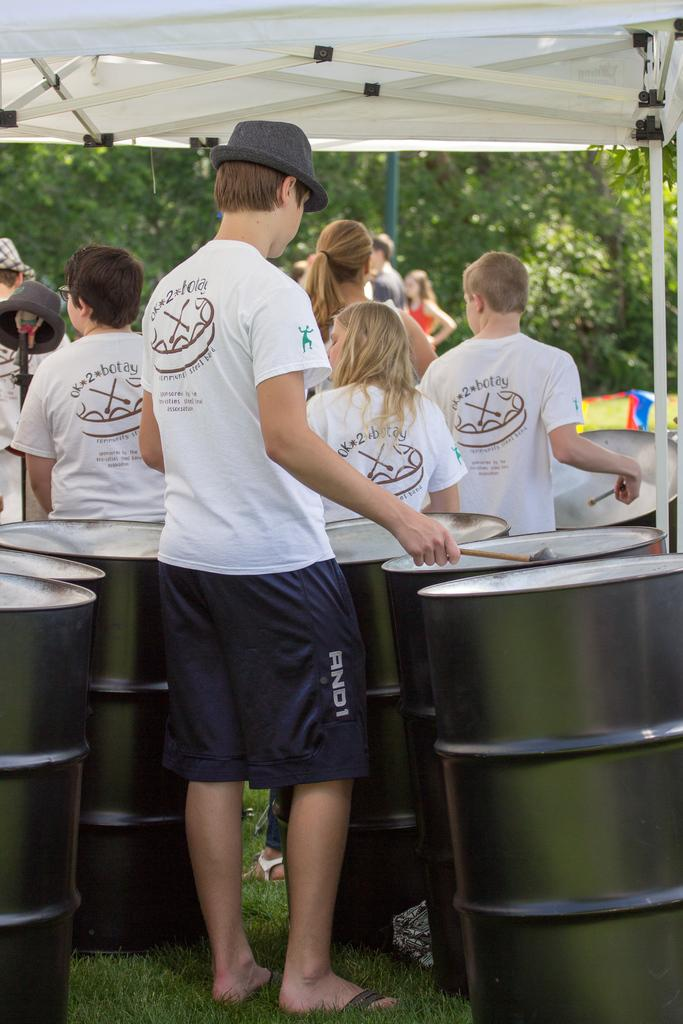<image>
Relay a brief, clear account of the picture shown. some people with white shirts and the number 2 on them 